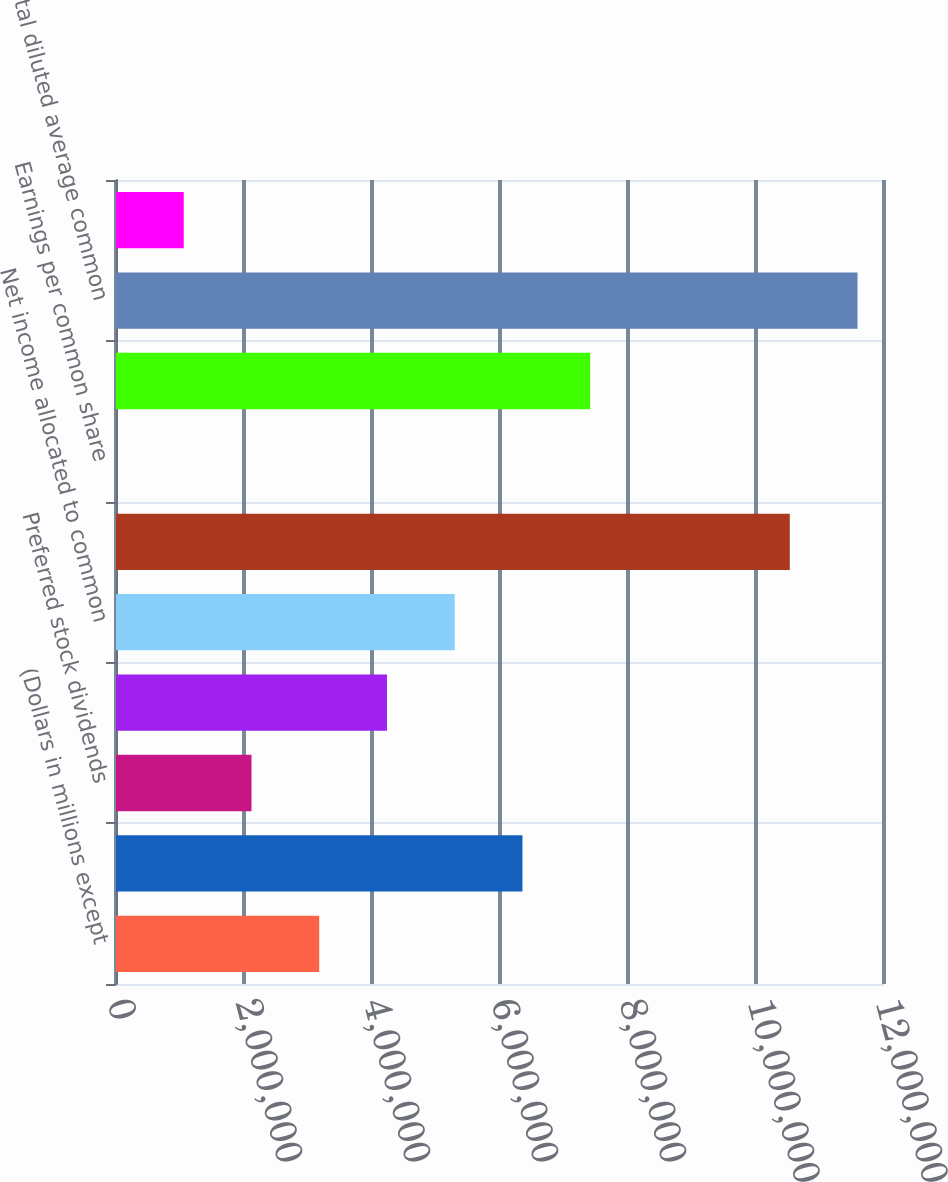Convert chart. <chart><loc_0><loc_0><loc_500><loc_500><bar_chart><fcel>(Dollars in millions except<fcel>Net income<fcel>Preferred stock dividends<fcel>Net income applicable to<fcel>Net income allocated to common<fcel>Average common shares issued<fcel>Earnings per common share<fcel>Dilutive potential common<fcel>Total diluted average common<fcel>Diluted earnings per common<nl><fcel>3.17536e+06<fcel>6.35072e+06<fcel>2.11691e+06<fcel>4.23381e+06<fcel>5.29227e+06<fcel>1.05278e+07<fcel>0.36<fcel>7.40917e+06<fcel>1.15863e+07<fcel>1.05845e+06<nl></chart> 